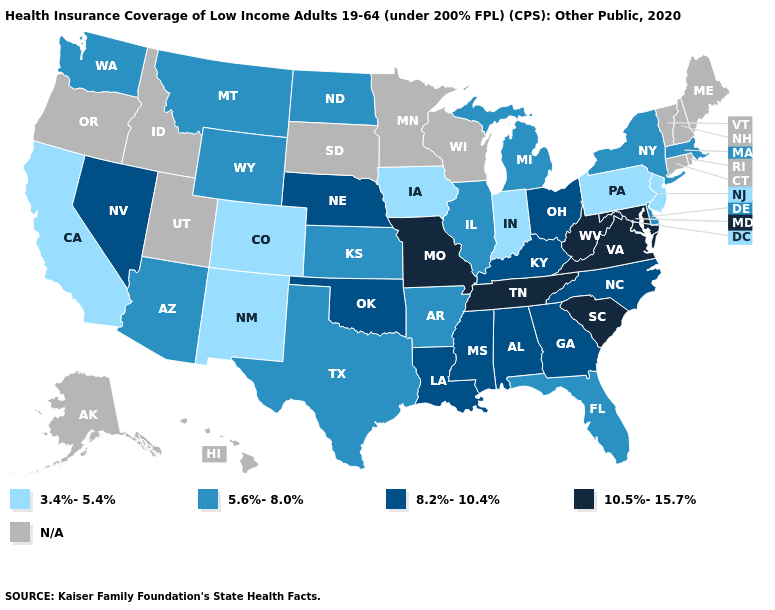What is the highest value in the Northeast ?
Answer briefly. 5.6%-8.0%. What is the value of Indiana?
Keep it brief. 3.4%-5.4%. What is the value of Connecticut?
Short answer required. N/A. Is the legend a continuous bar?
Give a very brief answer. No. What is the value of New Mexico?
Keep it brief. 3.4%-5.4%. Does Washington have the lowest value in the USA?
Write a very short answer. No. Name the states that have a value in the range 10.5%-15.7%?
Short answer required. Maryland, Missouri, South Carolina, Tennessee, Virginia, West Virginia. What is the highest value in the USA?
Keep it brief. 10.5%-15.7%. Among the states that border Massachusetts , which have the lowest value?
Keep it brief. New York. Name the states that have a value in the range 3.4%-5.4%?
Be succinct. California, Colorado, Indiana, Iowa, New Jersey, New Mexico, Pennsylvania. What is the value of New York?
Write a very short answer. 5.6%-8.0%. Does Indiana have the lowest value in the USA?
Write a very short answer. Yes. Name the states that have a value in the range 10.5%-15.7%?
Keep it brief. Maryland, Missouri, South Carolina, Tennessee, Virginia, West Virginia. Which states have the lowest value in the MidWest?
Write a very short answer. Indiana, Iowa. 